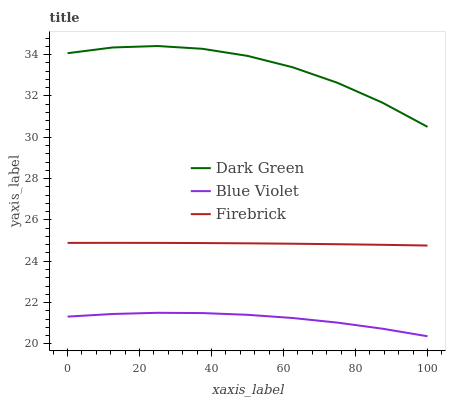Does Blue Violet have the minimum area under the curve?
Answer yes or no. Yes. Does Dark Green have the maximum area under the curve?
Answer yes or no. Yes. Does Dark Green have the minimum area under the curve?
Answer yes or no. No. Does Blue Violet have the maximum area under the curve?
Answer yes or no. No. Is Firebrick the smoothest?
Answer yes or no. Yes. Is Dark Green the roughest?
Answer yes or no. Yes. Is Blue Violet the smoothest?
Answer yes or no. No. Is Blue Violet the roughest?
Answer yes or no. No. Does Blue Violet have the lowest value?
Answer yes or no. Yes. Does Dark Green have the lowest value?
Answer yes or no. No. Does Dark Green have the highest value?
Answer yes or no. Yes. Does Blue Violet have the highest value?
Answer yes or no. No. Is Blue Violet less than Dark Green?
Answer yes or no. Yes. Is Dark Green greater than Firebrick?
Answer yes or no. Yes. Does Blue Violet intersect Dark Green?
Answer yes or no. No. 